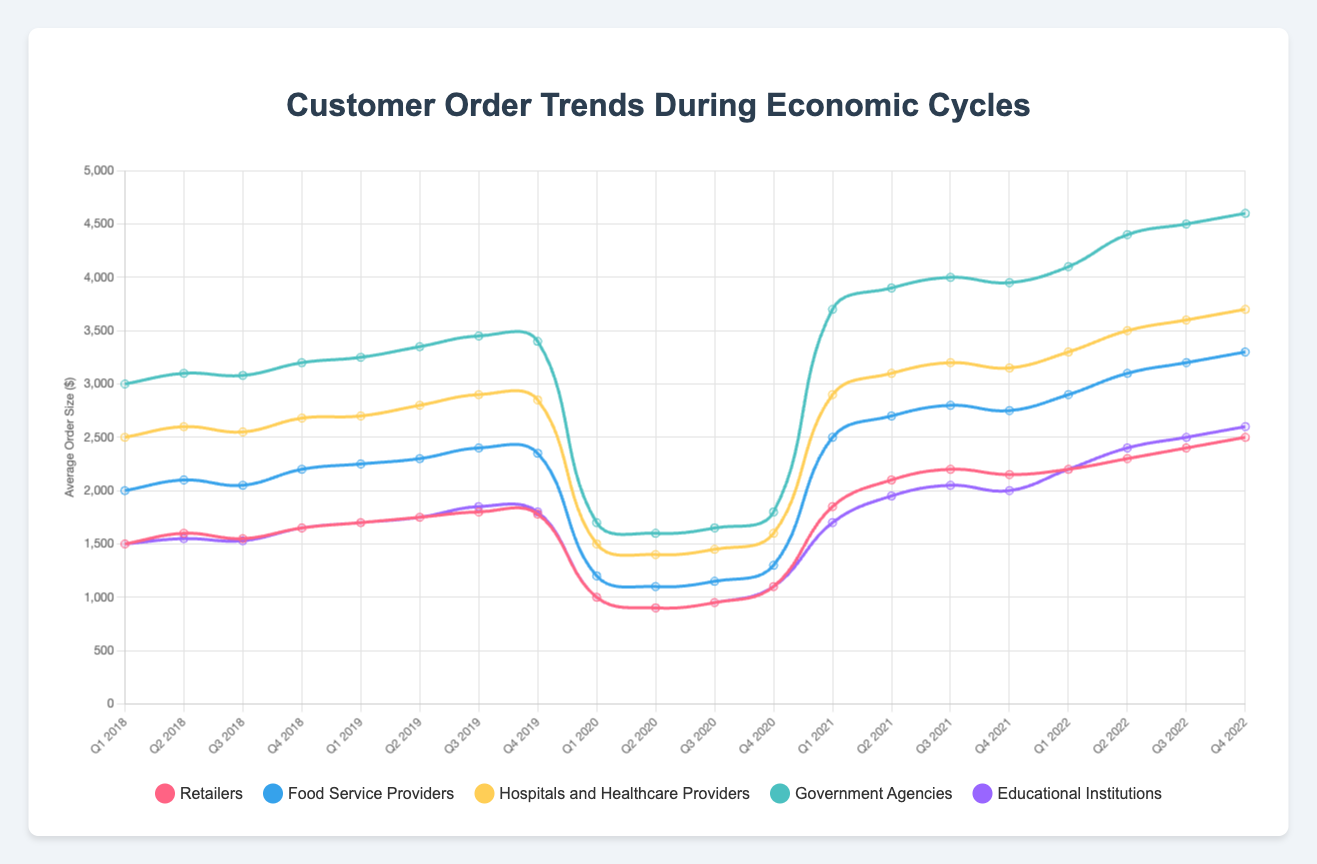Which customer segment had the highest average order size in Q2 2021? To find this, look at the average order sizes for each customer segment in Q2 2021. The values are Retailers (2100), Food Service Providers (2700), Hospitals and Healthcare Providers (3100), Government Agencies (3900), and Educational Institutions (1950). The highest is for Government Agencies at 3900.
Answer: Government Agencies How did the order frequency of Food Service Providers change from Q1 2020 to Q2 2020? Look at the order frequency data for Food Service Providers in Q1 and Q2 2020. In Q1 2020, it is 12, and in Q2 2020, it is 10. The order frequency decreased by 2.
Answer: Decreased by 2 Which customer segment had the largest increase in average order size from Q4 2020 to Q4 2021? First, calculate the differences in average order sizes for each segment from Q4 2020 to Q4 2021: Retailers (2150 - 1100 = 1050), Food Service Providers (2750 - 1300 = 1450), Hospitals and Healthcare Providers (3150 - 1600 = 1550), Government Agencies (3950 - 1800 = 2150), Educational Institutions (2000 - 1100 = 900). The largest increase is seen in Government Agencies, with an increase of 2150.
Answer: Government Agencies What was the trend in order frequency for Educational Institutions from Q1 2020 to Q1 2021? Look at the order frequencies for Educational Institutions from Q1 2020 (9), Q2 2020 (7), Q3 2020 (8), Q4 2020 (10), and Q1 2021 (18). The trend shows a decrease from Q1 2020 to Q2 2020, maintaining low levels in Q3 and Q4 2020, and then a significant increase by Q1 2021.
Answer: Decrease then significant increase Compare the average order size of Retailers and Hospitals and Healthcare Providers in Q1 2022. Which is higher? For Q1 2022, the average order size for Retailers is 2200, and for Hospitals and Healthcare Providers, it is 3300. The average order size for Hospitals and Healthcare Providers is higher.
Answer: Hospitals and Healthcare Providers During Q4 2019, which customer segment had the lowest order frequency? Review the order frequencies for Q4 2019: Retailers (19), Food Service Providers (23), Hospitals and Healthcare Providers (15), Government Agencies (12), and Educational Institutions (19). The lowest order frequency is for Government Agencies at 12.
Answer: Government Agencies What is the difference in average order size between Government Agencies and Food Service Providers in Q4 2022? In Q4 2022, the average order size is 4600 for Government Agencies and 3300 for Food Service Providers. The difference is 4600 - 3300 = 1300.
Answer: 1300 Which segment's order frequency did not change between Q2 2018 and Q3 2018? Review the order frequencies for Q2 2018 and Q3 2018 for each segment: Retailers (14, 13), Food Service Providers (18, 17), Hospitals and Healthcare Providers (12, 12), Government Agencies (9, 9), Educational Institutions (15, 14). Hospitals and Healthcare Providers and Government Agencies did not change.
Answer: Hospitals and Healthcare Providers, Government Agencies From Q1 2019 to Q1 2020, how did the average order size for Food Service Providers change? In Q1 2019, the average order size for Food Service Providers is 2250, and in Q1 2020 it is 1200. The difference is 2250 - 1200 = 1050. The average order size decreased by 1050.
Answer: Decreased by 1050 